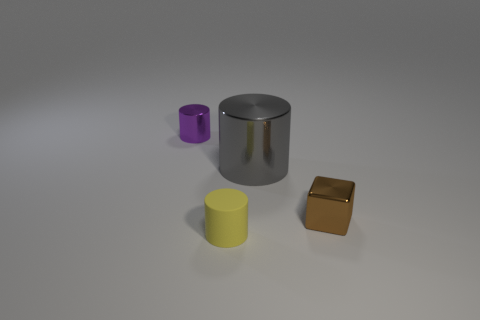There is another large object that is the same shape as the yellow object; what material is it?
Give a very brief answer. Metal. How many gray rubber blocks have the same size as the brown shiny block?
Keep it short and to the point. 0. There is another tiny cylinder that is made of the same material as the gray cylinder; what is its color?
Your response must be concise. Purple. Is the number of large green metallic balls less than the number of brown objects?
Your response must be concise. Yes. How many yellow objects are small things or metal cylinders?
Offer a very short reply. 1. What number of cylinders are both in front of the brown thing and to the left of the small yellow cylinder?
Ensure brevity in your answer.  0. Are the purple object and the big cylinder made of the same material?
Your answer should be very brief. Yes. There is a yellow matte thing that is the same size as the purple object; what shape is it?
Provide a short and direct response. Cylinder. Are there more tiny gray matte blocks than large gray metal cylinders?
Offer a very short reply. No. There is a thing that is right of the yellow cylinder and on the left side of the shiny block; what material is it made of?
Ensure brevity in your answer.  Metal. 